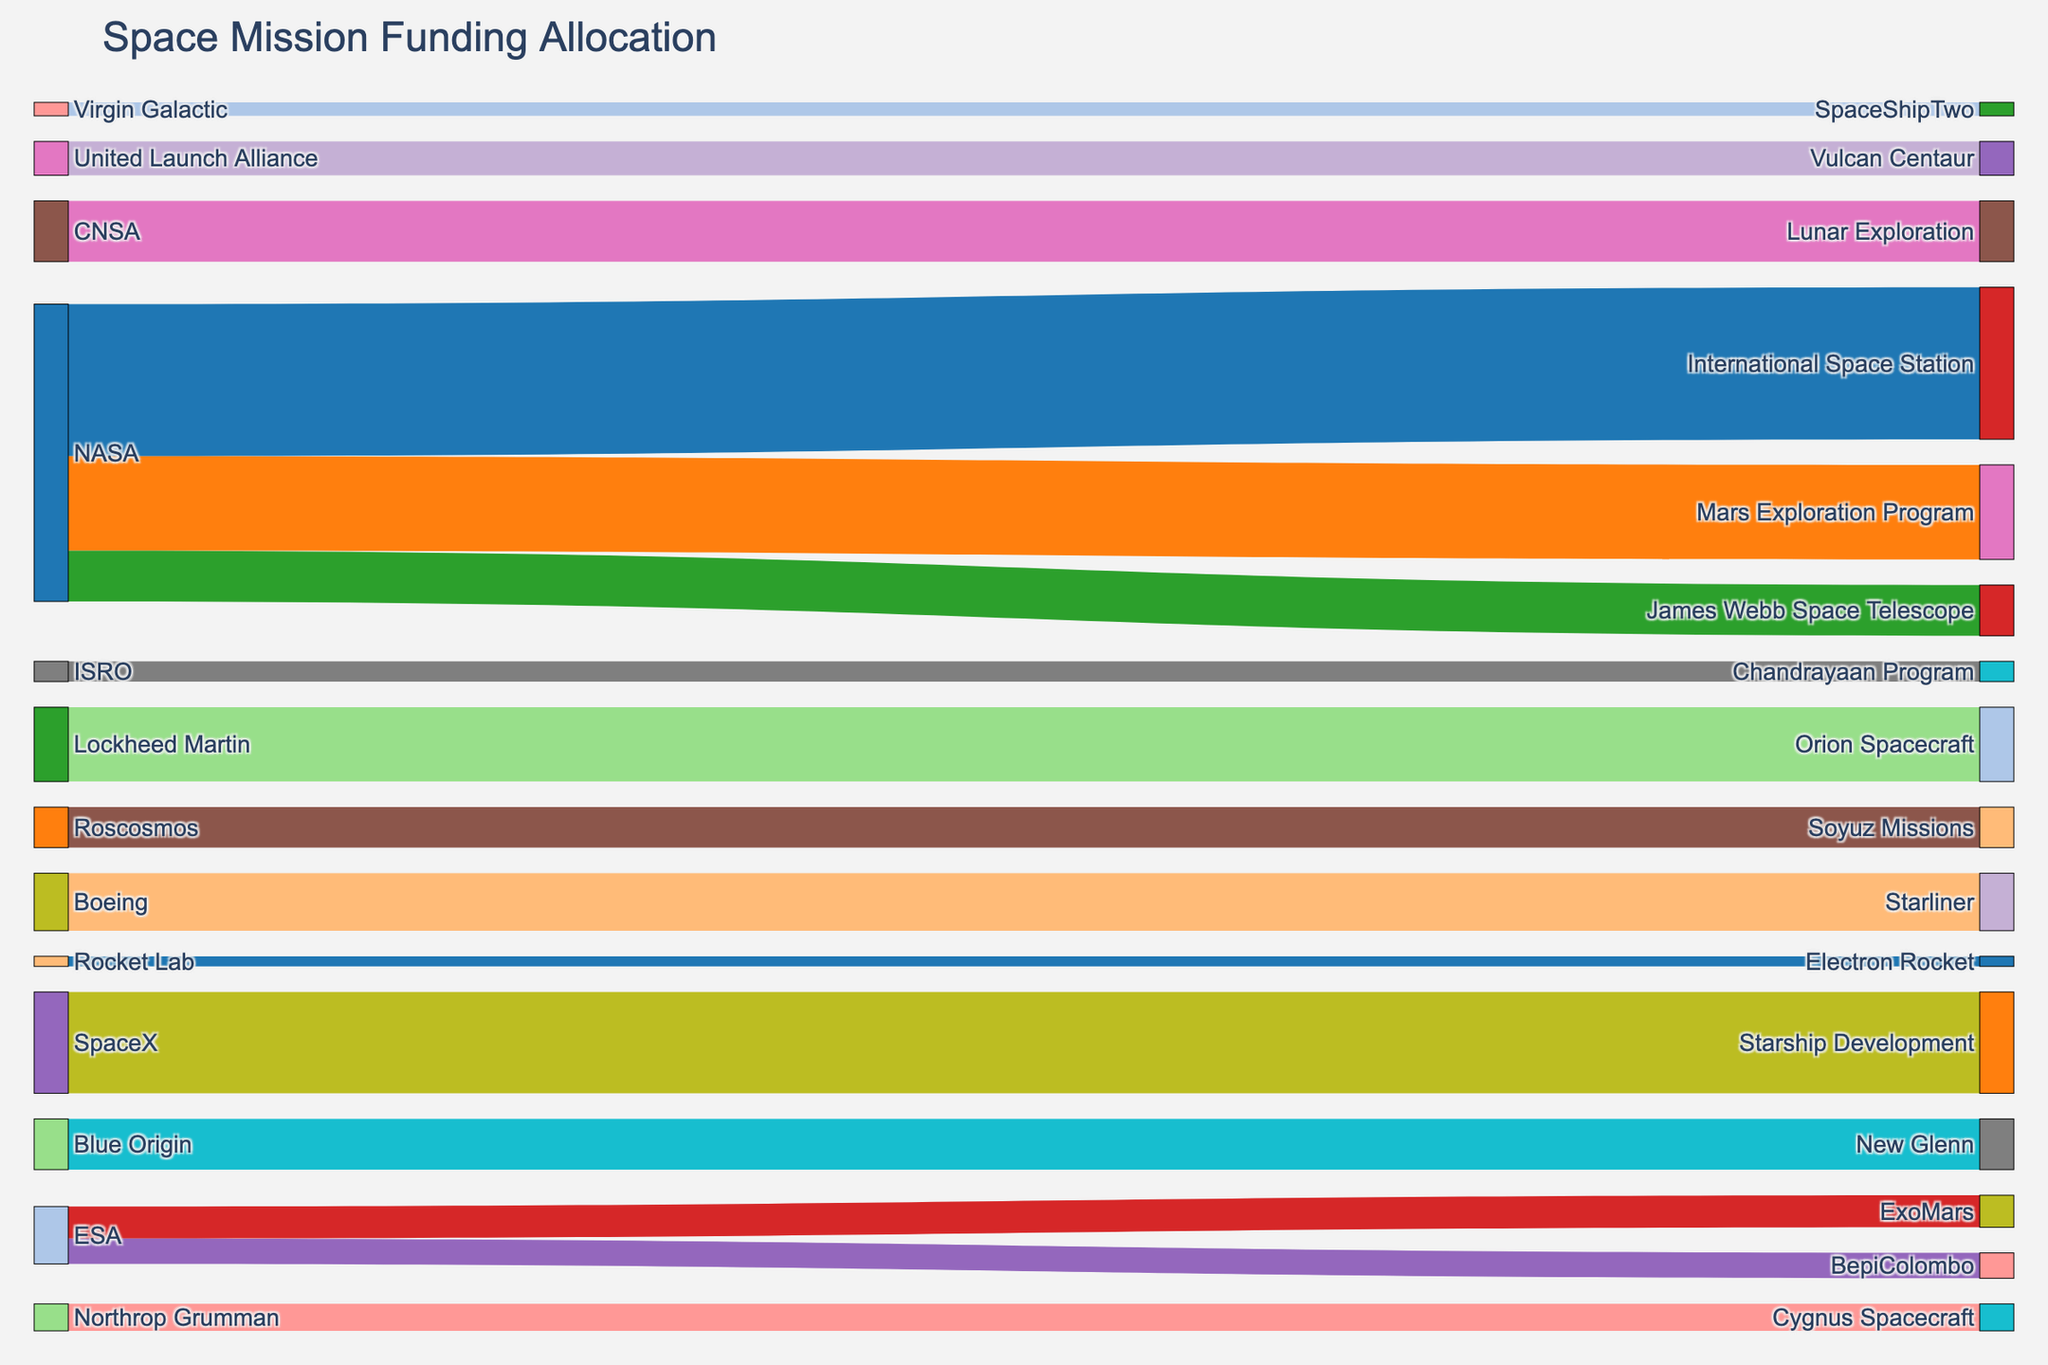what's the title of the figure? The title of the figure is displayed at the top of the chart. It provides a summary of the data visualized, which in this case is "Space Mission Funding Allocation".
Answer: Space Mission Funding Allocation Which source provides the most funding to a single mission? Check the figure for the source node with the largest flow to a target node. The largest flow is from NASA to the International Space Station.
Answer: NASA what's the total amount of funding allocated by NASA? Calculate the sum of all individual funding amounts from NASA to different missions: $4500 (International Space Station) + $2800 (Mars Exploration Program) + $1500 (James Webb Space Telescope) = $8800
Answer: $8800 Which target mission received the highest amount of funding? Look for the target node with the largest incoming flow. The International Space Station received $4500 from NASA, which is the highest funding amount.
Answer: International Space Station How does the funding amount for SpaceX's Starship Development compare to Blue Origin's New Glenn? Compare the value of the flows directed to each mission. SpaceX's Starship Development has $3000, while Blue Origin's New Glenn has $1500.
Answer: SpaceX's Starship Development has $1500 more funding than Blue Origin's New Glenn What's the combined funding allocation for lunar-related missions? Identify lunar-related missions and sum their funding: Lunar Exploration (CNSA, $1800) + Chandrayaan Program (ISRO, $600) = $2400
Answer: $2400 What is the total funding contribution from private companies? Add the funding amounts from private companies: SpaceX ($3000) + Blue Origin ($1500) + Virgin Galactic ($400) + Boeing ($1700) + Northrop Grumman ($800) + United Launch Alliance ($1000) + Rocket Lab ($300) = $8700
Answer: $8700 Which organizations fund space telescope missions? Identify the target nodes related to space telescopes and trace back to their source nodes. The James Webb Space Telescope is funded by NASA.
Answer: NASA How many distinct organizations are involved in funding? Count the unique entities (sources) in the figure: NASA, ESA, Roscosmos, CNSA, ISRO, SpaceX, Blue Origin, Virgin Galactic, Boeing, Lockheed Martin, Northrop Grumman, United Launch Alliance, Rocket Lab.
Answer: 13 Which has more funding, NASA's James Webb Space Telescope or Roscosmos's Soyuz Missions? Compare the funding of each mission: James Webb Space Telescope ($1500) versus Soyuz Missions ($1200).
Answer: James Webb Space Telescope 